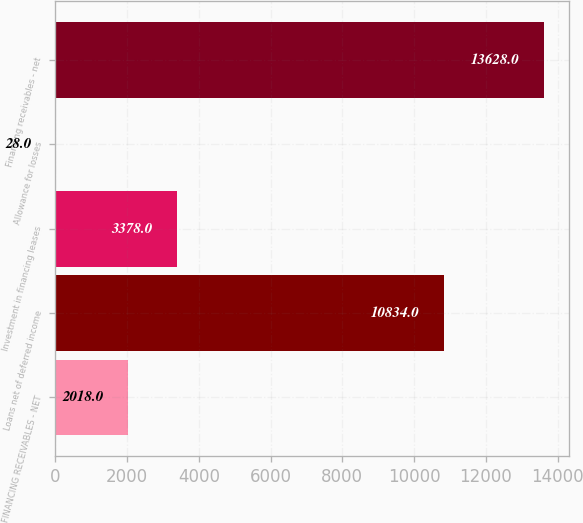Convert chart to OTSL. <chart><loc_0><loc_0><loc_500><loc_500><bar_chart><fcel>FINANCING RECEIVABLES - NET<fcel>Loans net of deferred income<fcel>Investment in financing leases<fcel>Allowance for losses<fcel>Financing receivables - net<nl><fcel>2018<fcel>10834<fcel>3378<fcel>28<fcel>13628<nl></chart> 